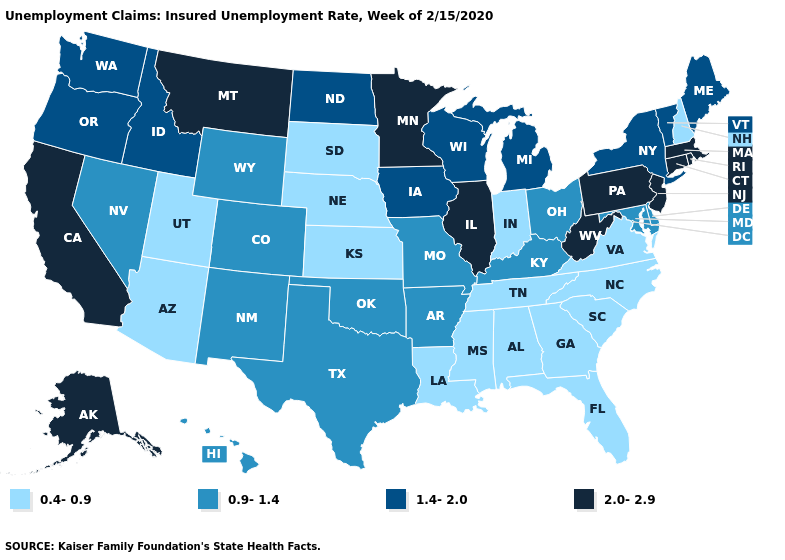Which states have the lowest value in the Northeast?
Keep it brief. New Hampshire. Does the map have missing data?
Be succinct. No. How many symbols are there in the legend?
Be succinct. 4. What is the value of Delaware?
Concise answer only. 0.9-1.4. Which states have the highest value in the USA?
Quick response, please. Alaska, California, Connecticut, Illinois, Massachusetts, Minnesota, Montana, New Jersey, Pennsylvania, Rhode Island, West Virginia. Name the states that have a value in the range 0.4-0.9?
Concise answer only. Alabama, Arizona, Florida, Georgia, Indiana, Kansas, Louisiana, Mississippi, Nebraska, New Hampshire, North Carolina, South Carolina, South Dakota, Tennessee, Utah, Virginia. Does Louisiana have a lower value than Utah?
Keep it brief. No. What is the lowest value in states that border New Mexico?
Concise answer only. 0.4-0.9. Is the legend a continuous bar?
Give a very brief answer. No. Name the states that have a value in the range 0.4-0.9?
Short answer required. Alabama, Arizona, Florida, Georgia, Indiana, Kansas, Louisiana, Mississippi, Nebraska, New Hampshire, North Carolina, South Carolina, South Dakota, Tennessee, Utah, Virginia. Name the states that have a value in the range 2.0-2.9?
Give a very brief answer. Alaska, California, Connecticut, Illinois, Massachusetts, Minnesota, Montana, New Jersey, Pennsylvania, Rhode Island, West Virginia. What is the value of North Carolina?
Write a very short answer. 0.4-0.9. Among the states that border West Virginia , which have the lowest value?
Short answer required. Virginia. Does Pennsylvania have a higher value than Illinois?
Write a very short answer. No. What is the highest value in states that border New York?
Short answer required. 2.0-2.9. 